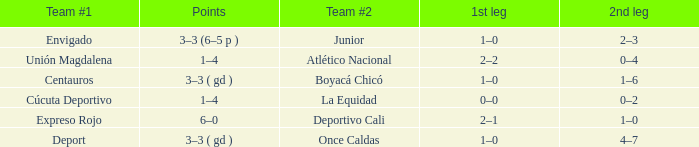What is the 1st leg with a junior team #2? 1–0. 